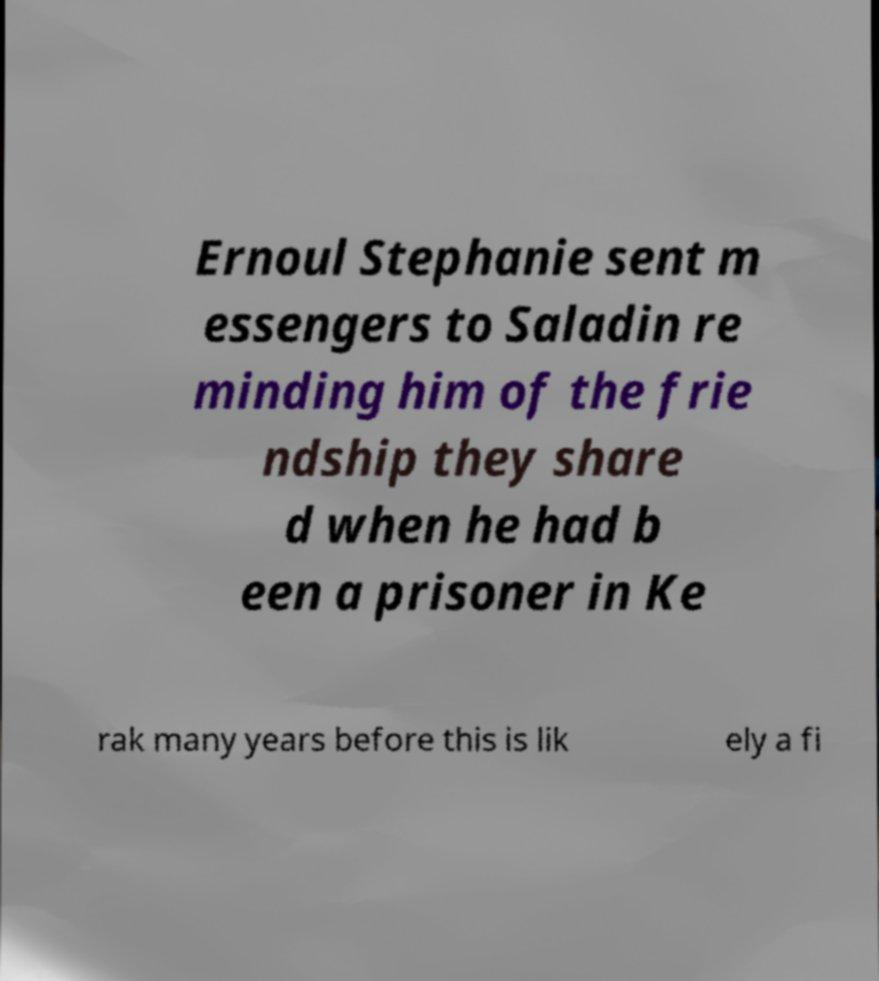I need the written content from this picture converted into text. Can you do that? Ernoul Stephanie sent m essengers to Saladin re minding him of the frie ndship they share d when he had b een a prisoner in Ke rak many years before this is lik ely a fi 